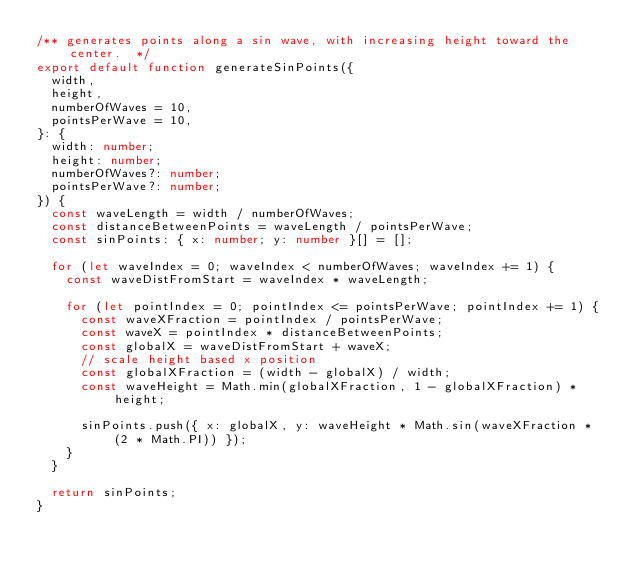Convert code to text. <code><loc_0><loc_0><loc_500><loc_500><_TypeScript_>/** generates points along a sin wave, with increasing height toward the center.  */
export default function generateSinPoints({
  width,
  height,
  numberOfWaves = 10,
  pointsPerWave = 10,
}: {
  width: number;
  height: number;
  numberOfWaves?: number;
  pointsPerWave?: number;
}) {
  const waveLength = width / numberOfWaves;
  const distanceBetweenPoints = waveLength / pointsPerWave;
  const sinPoints: { x: number; y: number }[] = [];

  for (let waveIndex = 0; waveIndex < numberOfWaves; waveIndex += 1) {
    const waveDistFromStart = waveIndex * waveLength;

    for (let pointIndex = 0; pointIndex <= pointsPerWave; pointIndex += 1) {
      const waveXFraction = pointIndex / pointsPerWave;
      const waveX = pointIndex * distanceBetweenPoints;
      const globalX = waveDistFromStart + waveX;
      // scale height based x position
      const globalXFraction = (width - globalX) / width;
      const waveHeight = Math.min(globalXFraction, 1 - globalXFraction) * height;

      sinPoints.push({ x: globalX, y: waveHeight * Math.sin(waveXFraction * (2 * Math.PI)) });
    }
  }

  return sinPoints;
}
</code> 